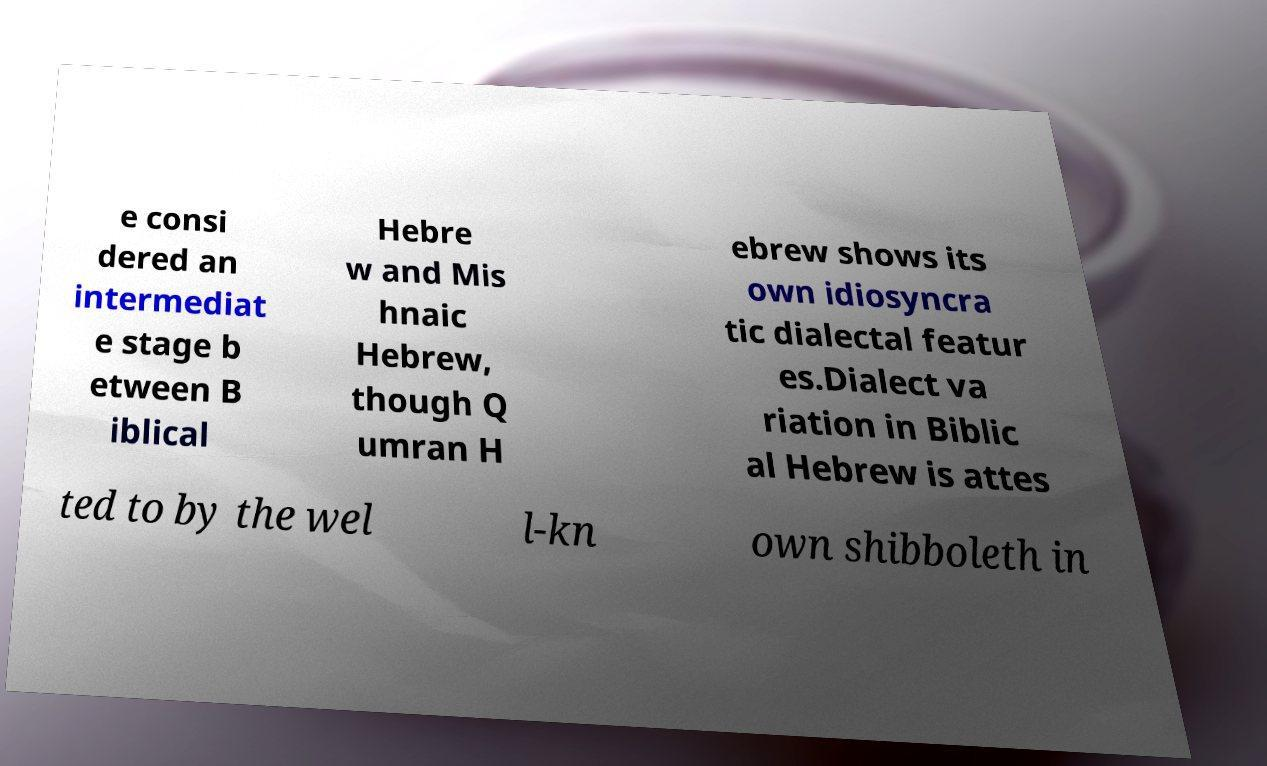Can you read and provide the text displayed in the image?This photo seems to have some interesting text. Can you extract and type it out for me? e consi dered an intermediat e stage b etween B iblical Hebre w and Mis hnaic Hebrew, though Q umran H ebrew shows its own idiosyncra tic dialectal featur es.Dialect va riation in Biblic al Hebrew is attes ted to by the wel l-kn own shibboleth in 